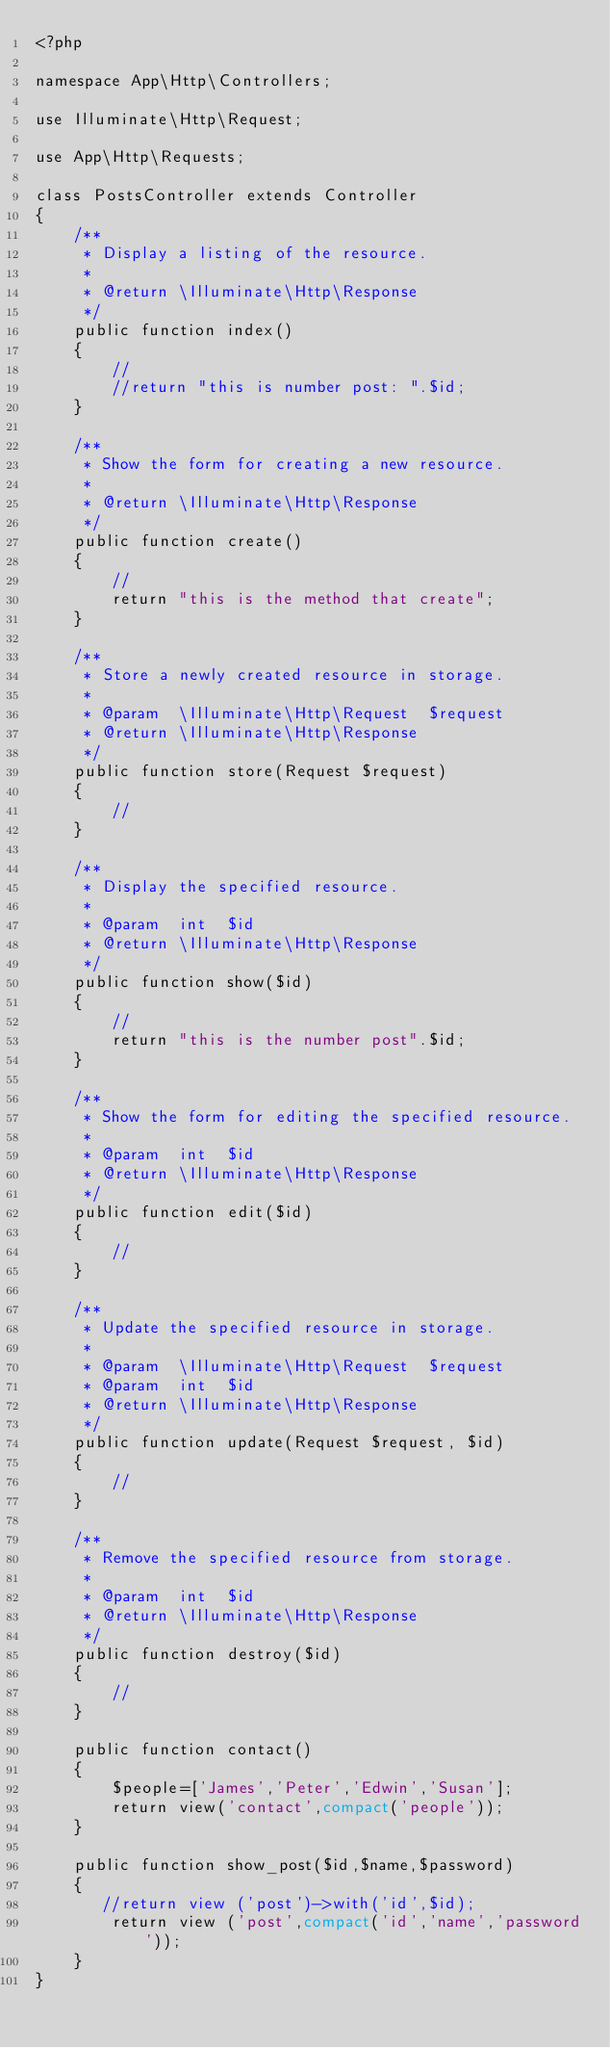Convert code to text. <code><loc_0><loc_0><loc_500><loc_500><_PHP_><?php

namespace App\Http\Controllers;

use Illuminate\Http\Request;

use App\Http\Requests;

class PostsController extends Controller
{
    /**
     * Display a listing of the resource.
     *
     * @return \Illuminate\Http\Response
     */
    public function index()
    {
        //
        //return "this is number post: ".$id;
    }

    /**
     * Show the form for creating a new resource.
     *
     * @return \Illuminate\Http\Response
     */
    public function create()
    {
        //
        return "this is the method that create";
    }

    /**
     * Store a newly created resource in storage.
     *
     * @param  \Illuminate\Http\Request  $request
     * @return \Illuminate\Http\Response
     */
    public function store(Request $request)
    {
        //
    }

    /**
     * Display the specified resource.
     *
     * @param  int  $id
     * @return \Illuminate\Http\Response
     */
    public function show($id)
    {
        //
        return "this is the number post".$id;
    }

    /**
     * Show the form for editing the specified resource.
     *
     * @param  int  $id
     * @return \Illuminate\Http\Response
     */
    public function edit($id)
    {
        //
    }

    /**
     * Update the specified resource in storage.
     *
     * @param  \Illuminate\Http\Request  $request
     * @param  int  $id
     * @return \Illuminate\Http\Response
     */
    public function update(Request $request, $id)
    {
        //
    }

    /**
     * Remove the specified resource from storage.
     *
     * @param  int  $id
     * @return \Illuminate\Http\Response
     */
    public function destroy($id)
    {
        //
    }

    public function contact()
    {
        $people=['James','Peter','Edwin','Susan'];
        return view('contact',compact('people'));
    }

    public function show_post($id,$name,$password)
    {
       //return view ('post')->with('id',$id);
        return view ('post',compact('id','name','password'));
    }
}
</code> 